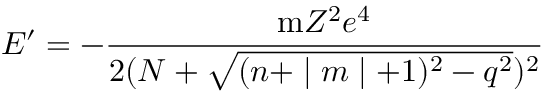Convert formula to latex. <formula><loc_0><loc_0><loc_500><loc_500>E ^ { \prime } = - \frac { m Z ^ { 2 } e ^ { 4 } } { 2 ( N + \sqrt { ( n + | m | + 1 ) ^ { 2 } - q ^ { 2 } } ) ^ { 2 } }</formula> 